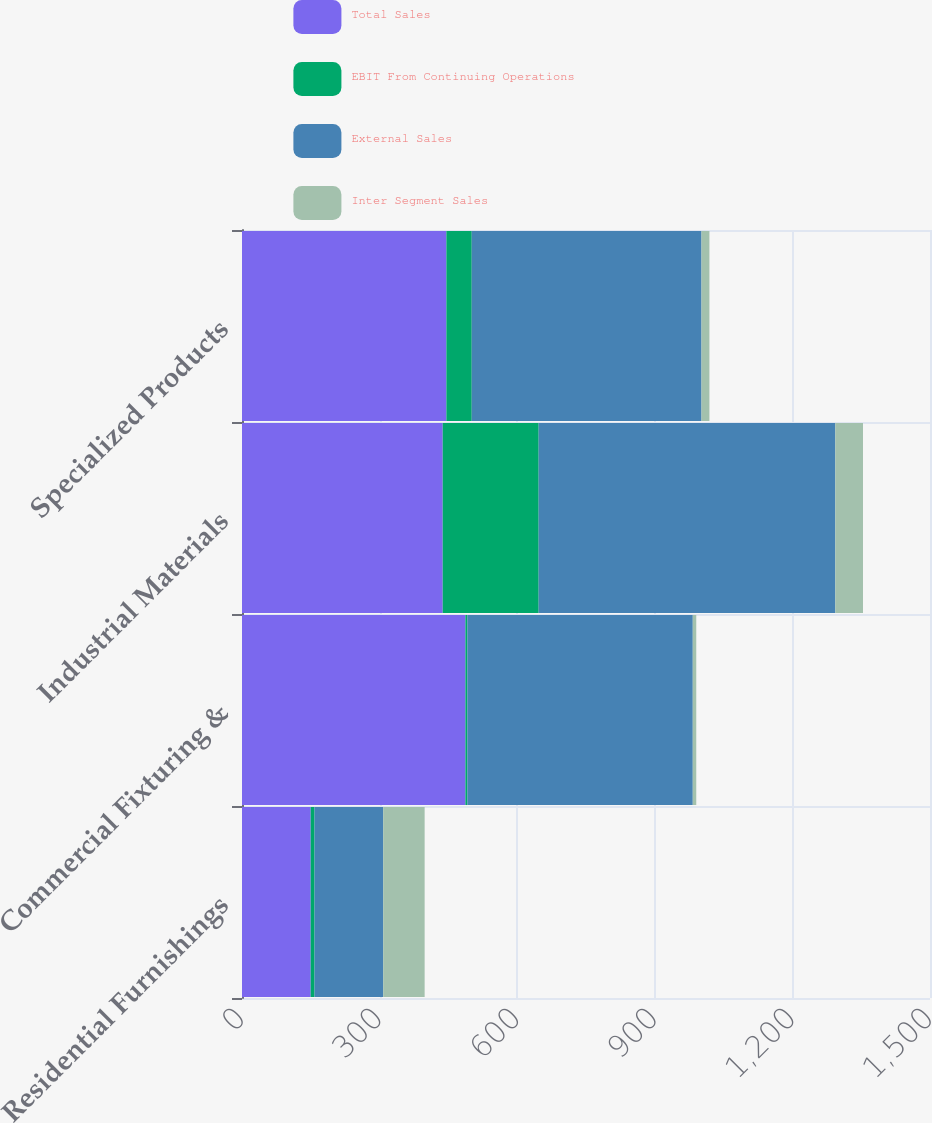<chart> <loc_0><loc_0><loc_500><loc_500><stacked_bar_chart><ecel><fcel>Residential Furnishings<fcel>Commercial Fixturing &<fcel>Industrial Materials<fcel>Specialized Products<nl><fcel>Total Sales<fcel>149.75<fcel>487.1<fcel>437.6<fcel>445.6<nl><fcel>EBIT From Continuing Operations<fcel>8.4<fcel>4.3<fcel>209.2<fcel>55.3<nl><fcel>External Sales<fcel>149.75<fcel>491.4<fcel>646.8<fcel>500.9<nl><fcel>Inter Segment Sales<fcel>90.3<fcel>7.6<fcel>60.3<fcel>17.3<nl></chart> 